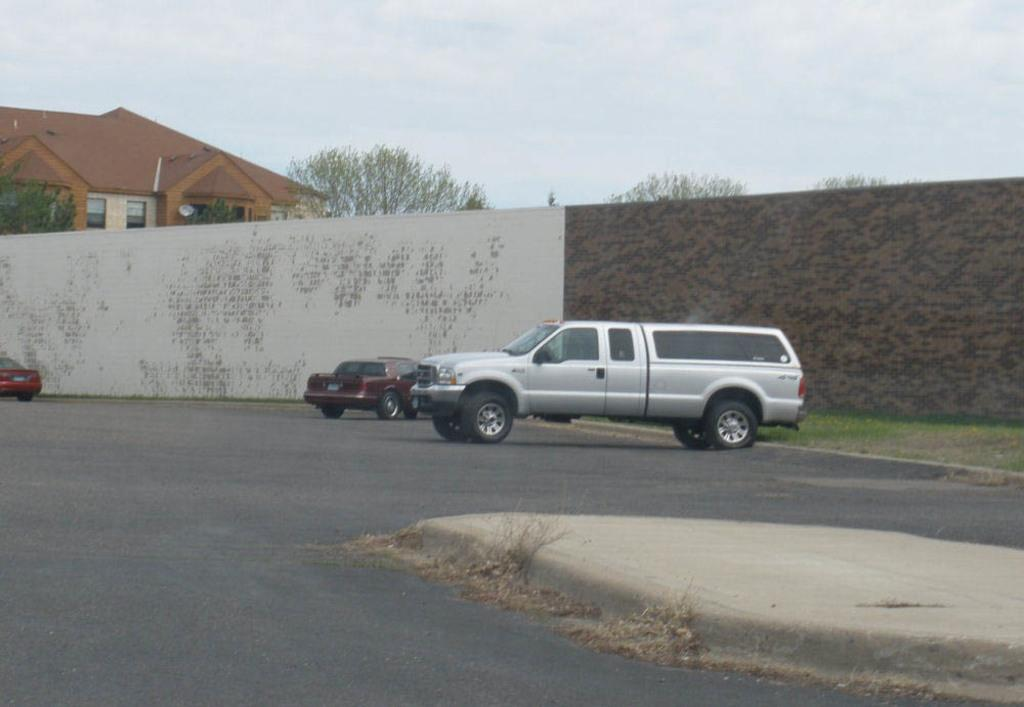What is on the road in the image? There is a car on the road in the image. What structure can be seen in the image? There is a wall in the image. What is located on the left side of the image? There is a house on the left side of the image. What is visible at the top of the image? The sky is visible at the top of the image. Can you tell me how many basketballs are on the roof of the house in the image? There are no basketballs present on the roof of the house in the image. What type of cherry is growing on the wall in the image? There are no cherries present on the wall in the image. 